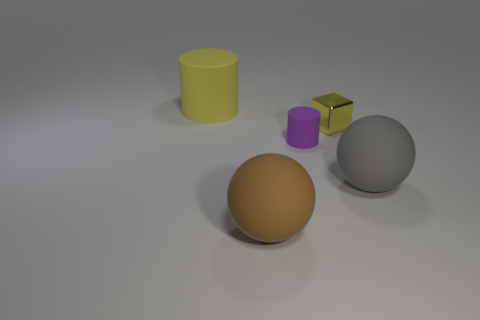Is the size of the rubber object that is left of the brown thing the same as the yellow object that is to the right of the small rubber thing?
Provide a short and direct response. No. Is the metal thing the same color as the large cylinder?
Offer a terse response. Yes. What is the material of the yellow object that is the same shape as the tiny purple object?
Provide a short and direct response. Rubber. There is a cylinder that is on the right side of the yellow matte cylinder to the left of the big gray matte object; how big is it?
Your answer should be very brief. Small. There is a yellow thing that is in front of the yellow matte cylinder; what is it made of?
Provide a succinct answer. Metal. What size is the purple thing that is the same material as the big gray thing?
Provide a short and direct response. Small. What number of other things are the same shape as the big brown object?
Provide a short and direct response. 1. There is a tiny rubber object; is it the same shape as the large object that is behind the gray ball?
Ensure brevity in your answer.  Yes. The object that is the same color as the big cylinder is what shape?
Offer a very short reply. Cube. Are there any cyan objects made of the same material as the brown sphere?
Offer a very short reply. No. 